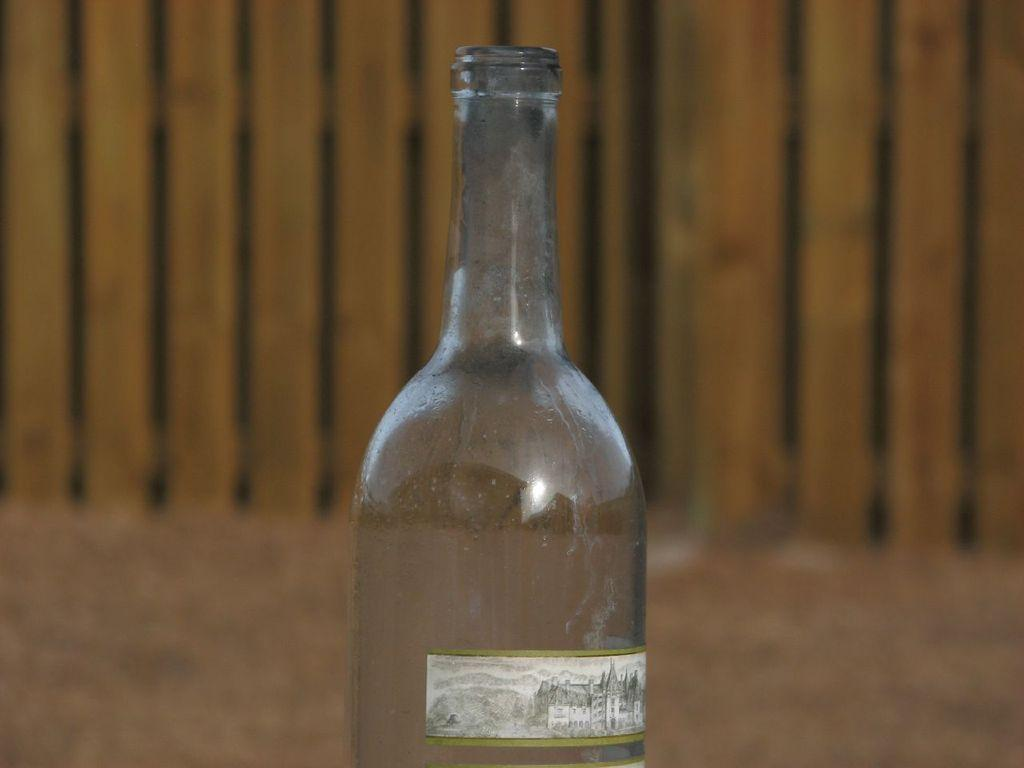What object is present in the image that appears to be empty? There is an empty bottle in the image. What songs are being sung by the cat in the image? There is no cat present in the image, and therefore no singing can be observed. 